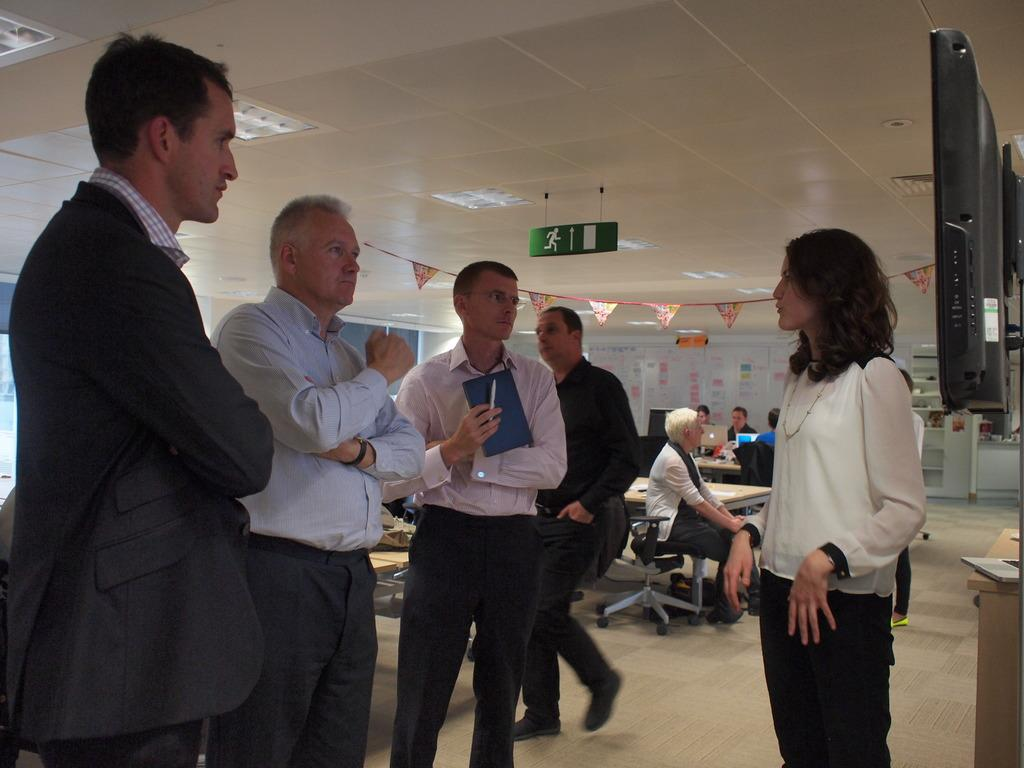How many people are in the image? There is a group of people in the image. What are the people in the image doing? The people are standing and discussing. What can be seen in the image that provides illumination? There are lights visible in the image. What type of bomb is being discussed by the people in the image? There is no mention or indication of a bomb in the image; the people are simply discussing. What territory does the governor of the group represent in the image? There is no governor or territory mentioned or depicted in the image. 